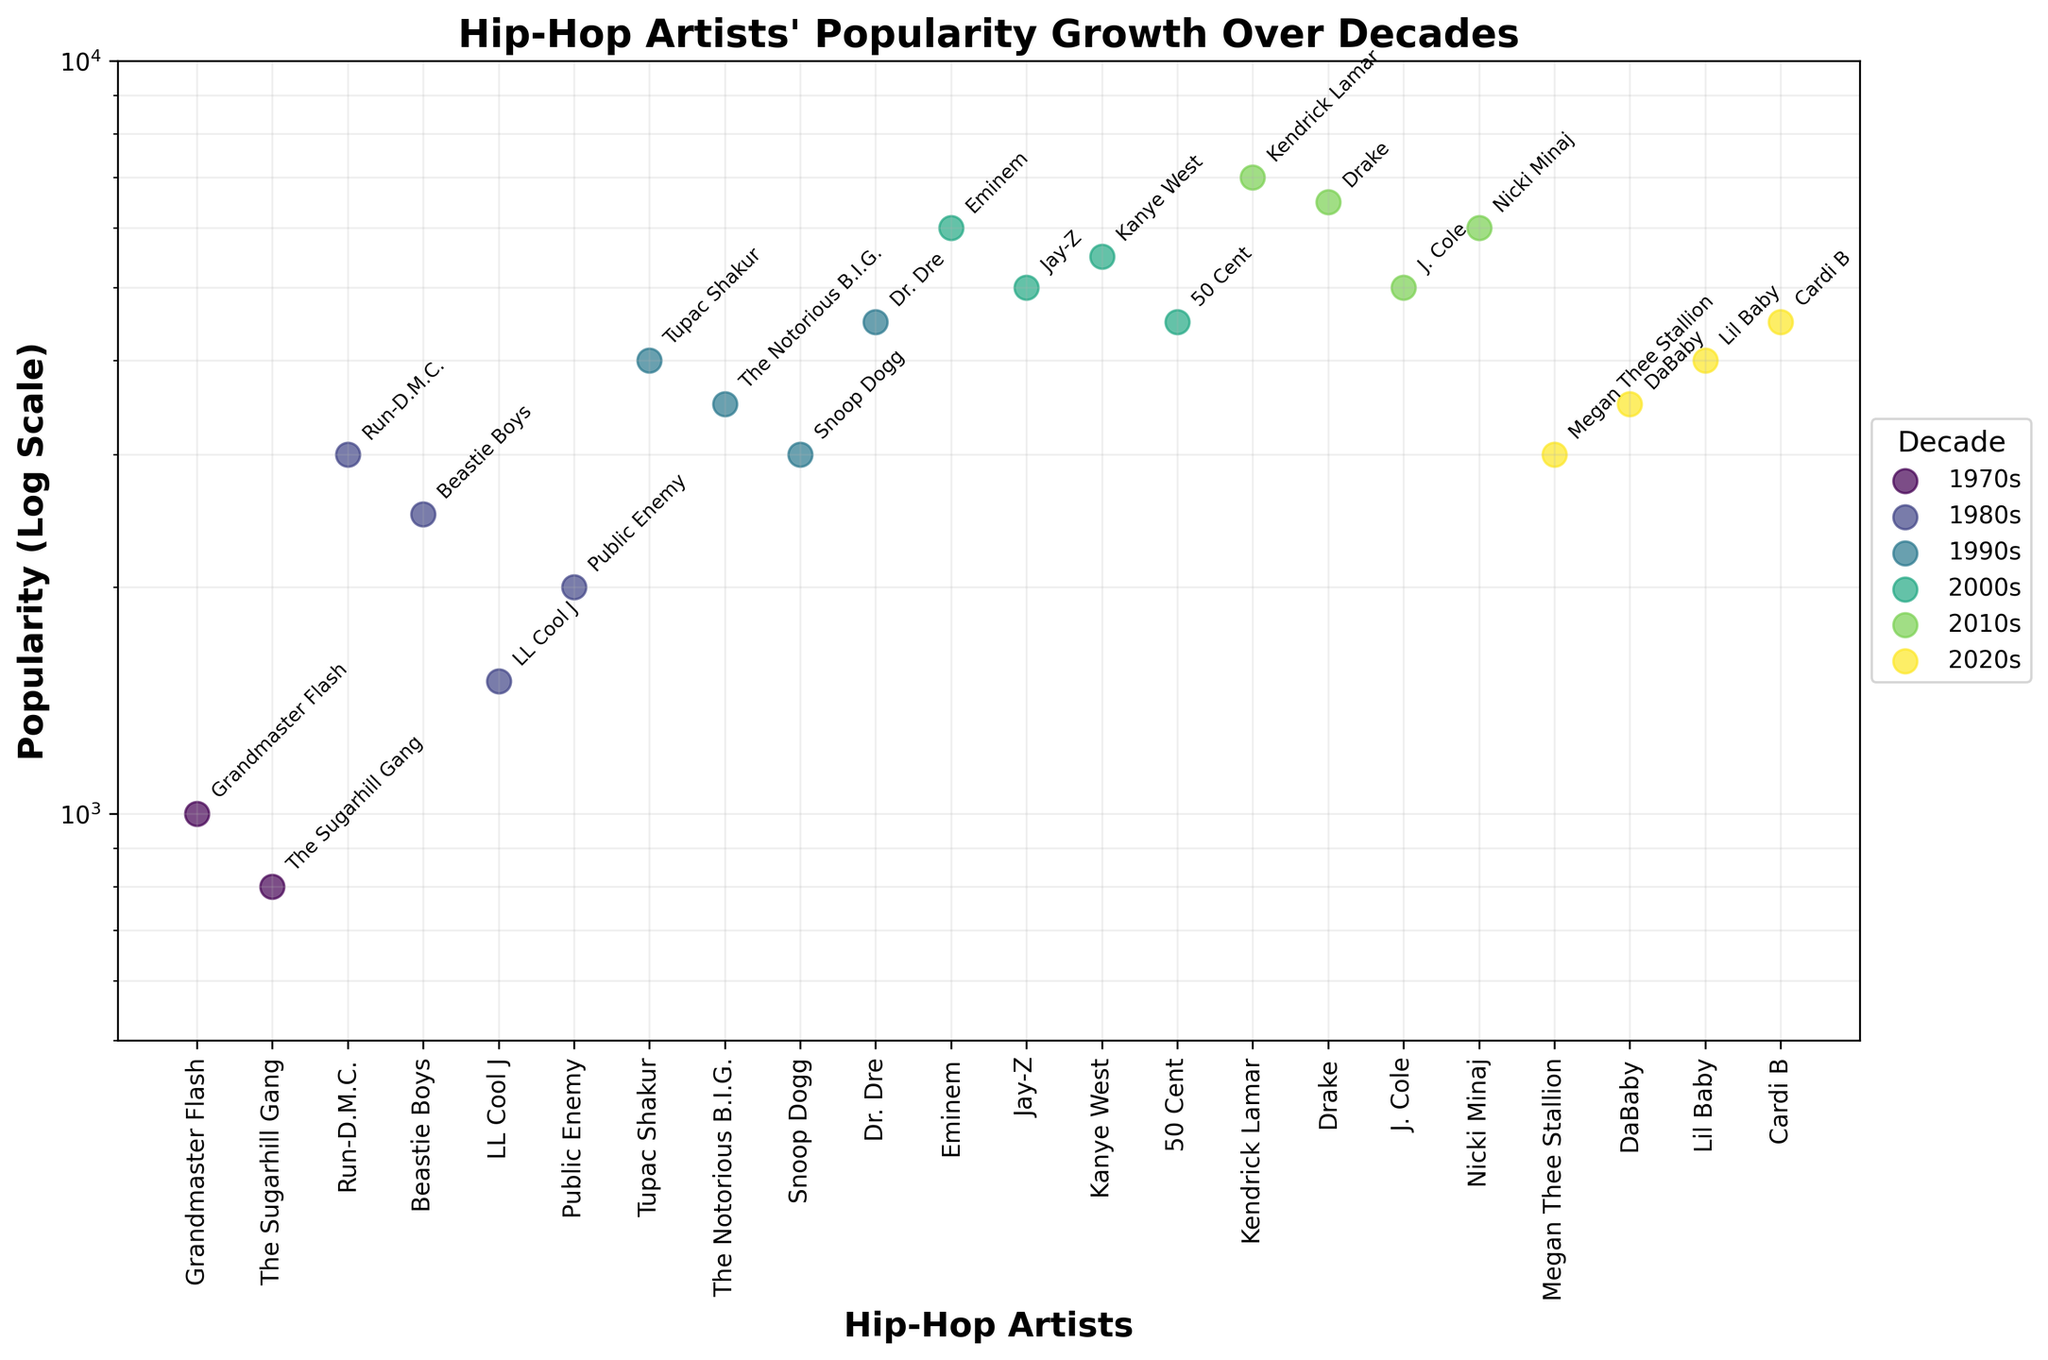Who is the most popular hip-hop artist in the 2010s? To find the most popular artist in the 2010s, locate the artist with the highest popularity value in that decade. According to the figure, Kendrick Lamar has the highest popularity value among artists in the 2010s.
Answer: Kendrick Lamar Which decades have artists whose popularity values fall within the logarithmic scale range of 1000 to 10000? To determine this, observe the y-axis (logarithmic scale) and check the popularity values of artists in each decade. The 1970s, 1980s, 1990s, 2000s, 2010s, and 2020s all have artists with popularity values ranging from 1000 to 10000 on the logarithmic scale.
Answer: 1970s, 1980s, 1990s, 2000s, 2010s, 2020s Which decade has the highest number of artists represented in the top half of the logarithmic scale? First, find the mid-point of the logarithmic scale. Then, identify the number of artists per decade with popularity above this mid-point. Popular artists in the upper half (>5000) are Jenkins Lamar, Drake, Nicki Minaj (2010s), Eminem, Jay-Z, Kanye West (2000s). The 2010s have the most with three artists in this range.
Answer: 2010s Who are the three most popular artists listed, regardless of the decade? Refer to the annotation of each data point, observe which artists have the highest values on the logarithmic scale. The three most popular artists overall are Kendrick Lamar, Drake, and Eminem.
Answer: Kendrick Lamar, Drake, Eminem Which artist from the 1990s has the highest popularity, and what is their popularity value? Examine the popularity values for the 1990s artists and identify the highest one. Dr. Dre, with a popularity value of 4500, is the highest.
Answer: Dr. Dre, 4500 What is the difference in popularity between the most and least popular artists of the 1980s? Identify the artists with the highest and lowest popularity values for the 1980s. The highest is Run-D.M.C. with 3000 and the lowest is LL Cool J with 1500. The difference is 3000 - 1500 = 1500.
Answer: 1500 Which two decades have the closest median popularity values? Calculate the median popularity for each decade and compare them. A simplified approach involves checking the midpoint value in lists ordered from low to high popularity. The 1970s (900) and the 1980s (2000) have the closest median values (sorted lists: 70s: [800, 1000], 80s: [1500, 2000, 2500, 3000]).
Answer: 1970s and 1980s 